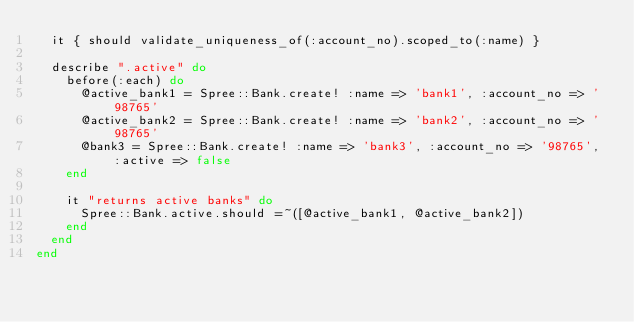<code> <loc_0><loc_0><loc_500><loc_500><_Ruby_>  it { should validate_uniqueness_of(:account_no).scoped_to(:name) }

  describe ".active" do
    before(:each) do
      @active_bank1 = Spree::Bank.create! :name => 'bank1', :account_no => '98765'
      @active_bank2 = Spree::Bank.create! :name => 'bank2', :account_no => '98765'
      @bank3 = Spree::Bank.create! :name => 'bank3', :account_no => '98765', :active => false
    end

    it "returns active banks" do
      Spree::Bank.active.should =~([@active_bank1, @active_bank2])
    end
  end
end</code> 